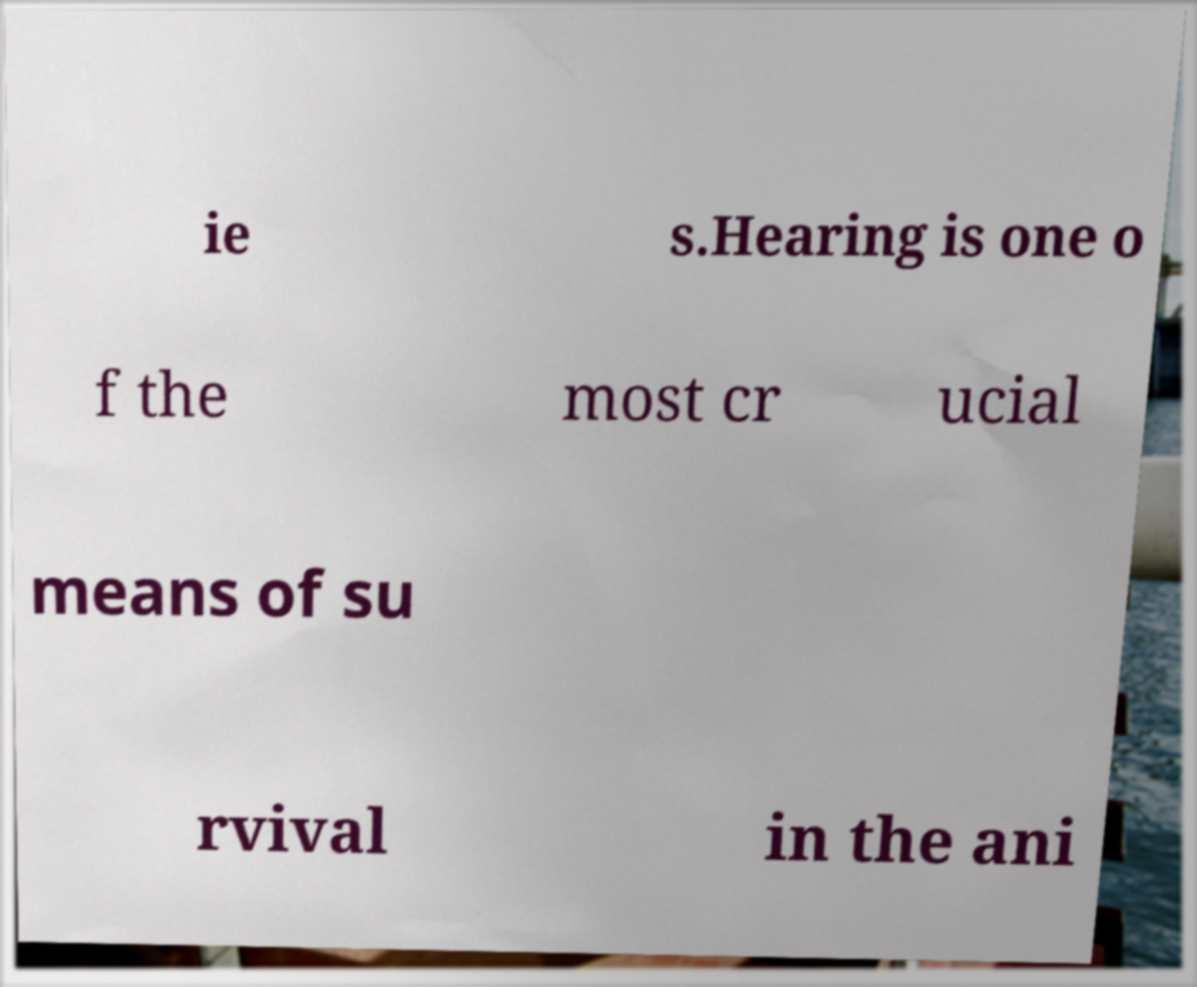Can you read and provide the text displayed in the image?This photo seems to have some interesting text. Can you extract and type it out for me? ie s.Hearing is one o f the most cr ucial means of su rvival in the ani 